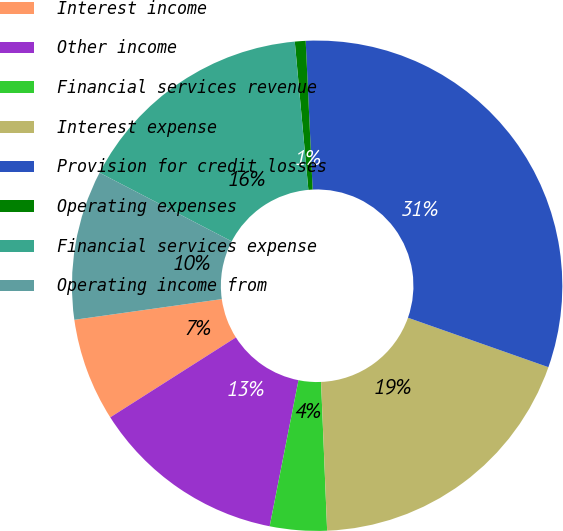Convert chart to OTSL. <chart><loc_0><loc_0><loc_500><loc_500><pie_chart><fcel>Interest income<fcel>Other income<fcel>Financial services revenue<fcel>Interest expense<fcel>Provision for credit losses<fcel>Operating expenses<fcel>Financial services expense<fcel>Operating income from<nl><fcel>6.8%<fcel>12.88%<fcel>3.75%<fcel>18.96%<fcel>31.13%<fcel>0.71%<fcel>15.92%<fcel>9.84%<nl></chart> 